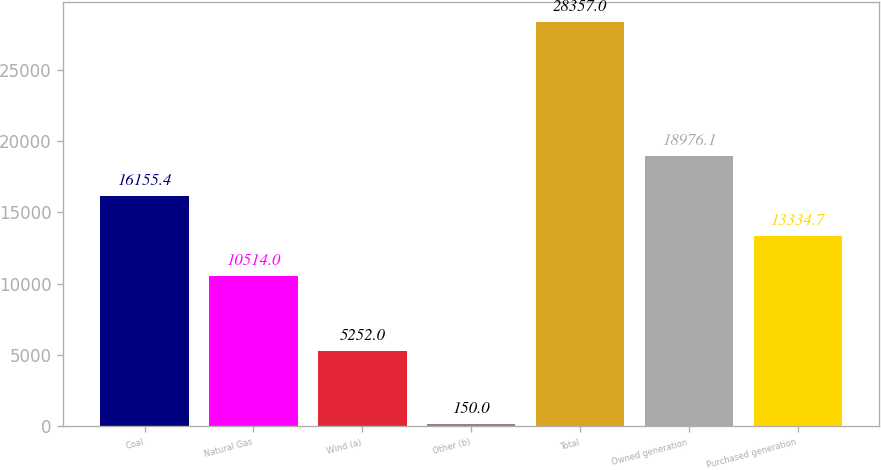Convert chart to OTSL. <chart><loc_0><loc_0><loc_500><loc_500><bar_chart><fcel>Coal<fcel>Natural Gas<fcel>Wind (a)<fcel>Other (b)<fcel>Total<fcel>Owned generation<fcel>Purchased generation<nl><fcel>16155.4<fcel>10514<fcel>5252<fcel>150<fcel>28357<fcel>18976.1<fcel>13334.7<nl></chart> 